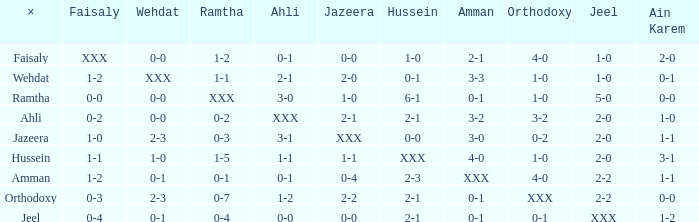What is x when faisaly has a 0-0 score? Ramtha. 